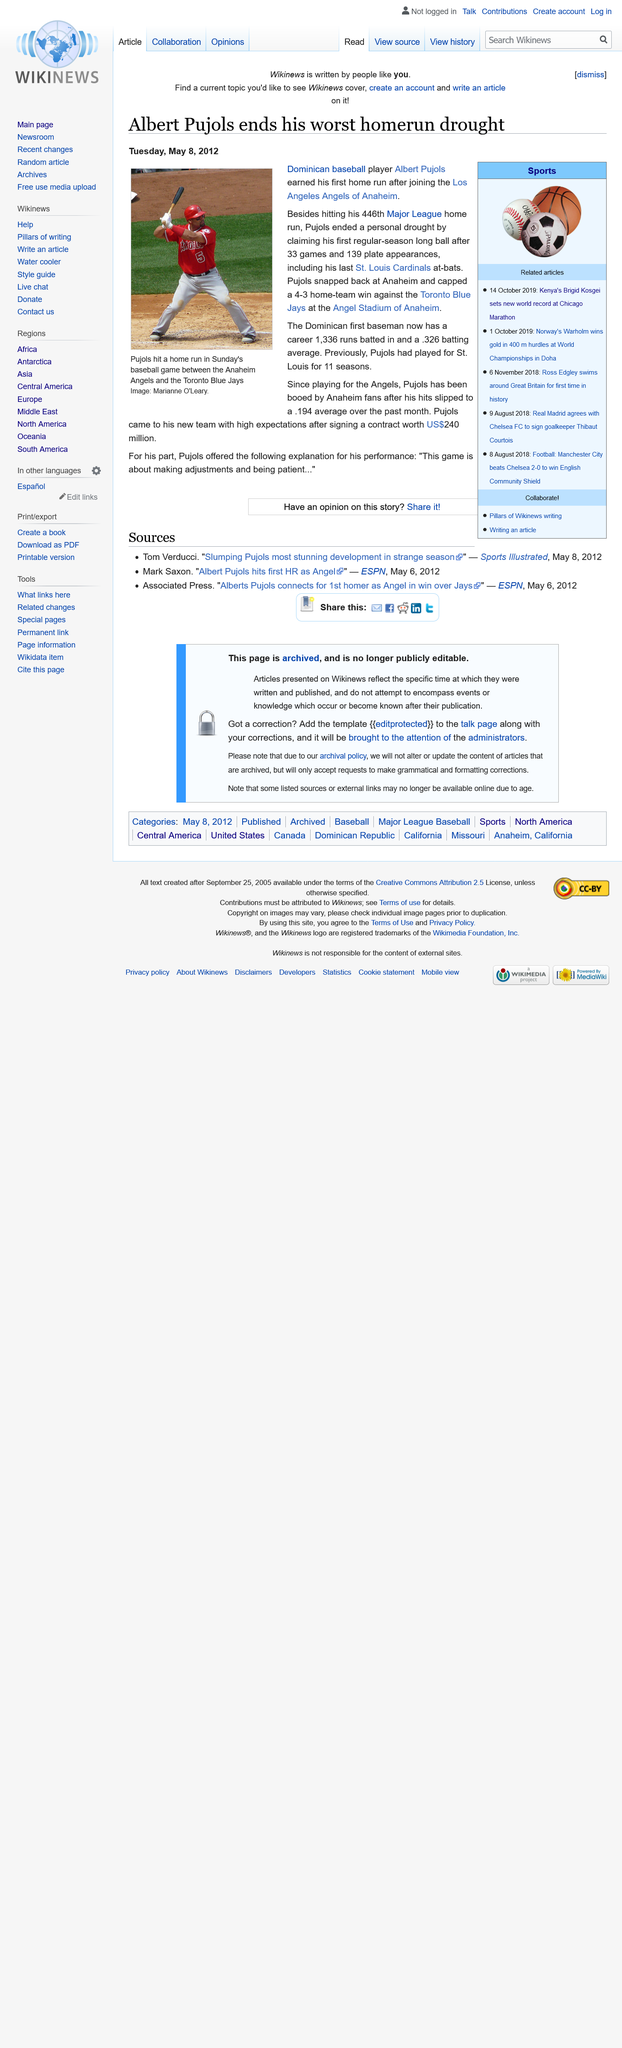Highlight a few significant elements in this photo. The contract between Pujols and the Los Angeles Angels of Anaheim is worth $240 million. Albert Pujols, a professional baseball player, played for the St Louis team for 11 seasons before recently joining the Los Angeles Angels of Anaheim. Since playing for the Angels, Pujols has been consistently booed by Anaheim fans. 